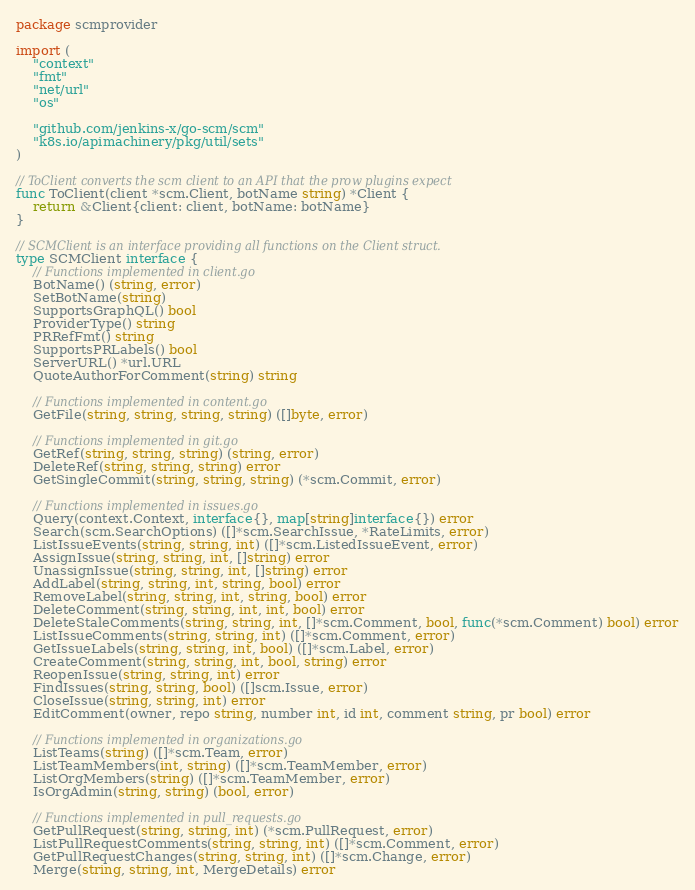<code> <loc_0><loc_0><loc_500><loc_500><_Go_>package scmprovider

import (
	"context"
	"fmt"
	"net/url"
	"os"

	"github.com/jenkins-x/go-scm/scm"
	"k8s.io/apimachinery/pkg/util/sets"
)

// ToClient converts the scm client to an API that the prow plugins expect
func ToClient(client *scm.Client, botName string) *Client {
	return &Client{client: client, botName: botName}
}

// SCMClient is an interface providing all functions on the Client struct.
type SCMClient interface {
	// Functions implemented in client.go
	BotName() (string, error)
	SetBotName(string)
	SupportsGraphQL() bool
	ProviderType() string
	PRRefFmt() string
	SupportsPRLabels() bool
	ServerURL() *url.URL
	QuoteAuthorForComment(string) string

	// Functions implemented in content.go
	GetFile(string, string, string, string) ([]byte, error)

	// Functions implemented in git.go
	GetRef(string, string, string) (string, error)
	DeleteRef(string, string, string) error
	GetSingleCommit(string, string, string) (*scm.Commit, error)

	// Functions implemented in issues.go
	Query(context.Context, interface{}, map[string]interface{}) error
	Search(scm.SearchOptions) ([]*scm.SearchIssue, *RateLimits, error)
	ListIssueEvents(string, string, int) ([]*scm.ListedIssueEvent, error)
	AssignIssue(string, string, int, []string) error
	UnassignIssue(string, string, int, []string) error
	AddLabel(string, string, int, string, bool) error
	RemoveLabel(string, string, int, string, bool) error
	DeleteComment(string, string, int, int, bool) error
	DeleteStaleComments(string, string, int, []*scm.Comment, bool, func(*scm.Comment) bool) error
	ListIssueComments(string, string, int) ([]*scm.Comment, error)
	GetIssueLabels(string, string, int, bool) ([]*scm.Label, error)
	CreateComment(string, string, int, bool, string) error
	ReopenIssue(string, string, int) error
	FindIssues(string, string, bool) ([]scm.Issue, error)
	CloseIssue(string, string, int) error
	EditComment(owner, repo string, number int, id int, comment string, pr bool) error

	// Functions implemented in organizations.go
	ListTeams(string) ([]*scm.Team, error)
	ListTeamMembers(int, string) ([]*scm.TeamMember, error)
	ListOrgMembers(string) ([]*scm.TeamMember, error)
	IsOrgAdmin(string, string) (bool, error)

	// Functions implemented in pull_requests.go
	GetPullRequest(string, string, int) (*scm.PullRequest, error)
	ListPullRequestComments(string, string, int) ([]*scm.Comment, error)
	GetPullRequestChanges(string, string, int) ([]*scm.Change, error)
	Merge(string, string, int, MergeDetails) error</code> 